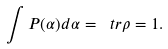Convert formula to latex. <formula><loc_0><loc_0><loc_500><loc_500>\text { } \int P ( \alpha ) d \alpha = \ t r \rho = 1 .</formula> 